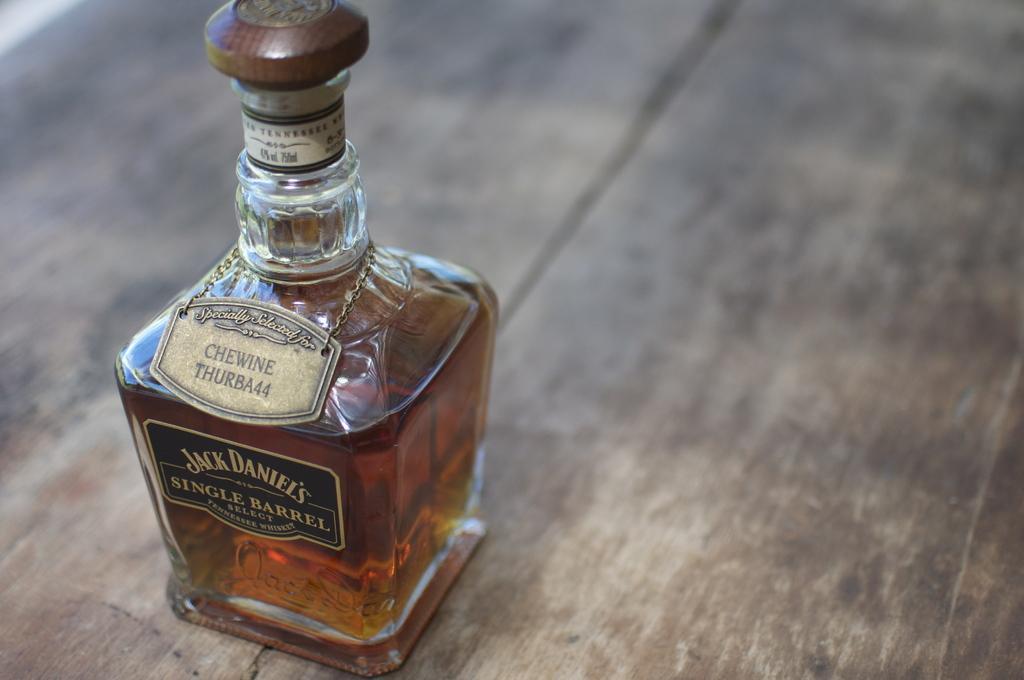How would you summarize this image in a sentence or two? In this image I can see a bottle. 